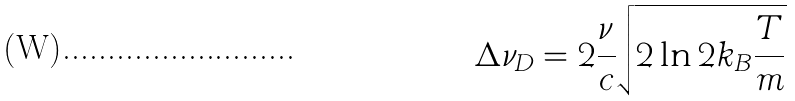Convert formula to latex. <formula><loc_0><loc_0><loc_500><loc_500>\Delta \nu _ { D } = 2 \frac { \nu } { c } \sqrt { 2 \ln 2 k _ { B } \frac { T } { m } }</formula> 